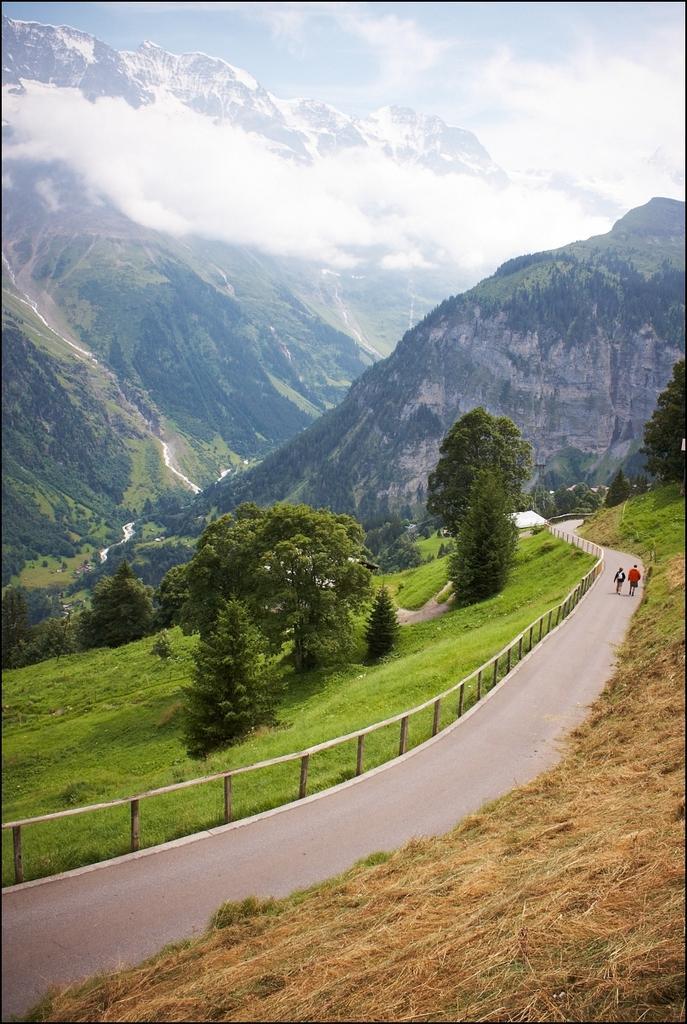Could you give a brief overview of what you see in this image? Here there are trees, people are walking on the road, this is sky. 